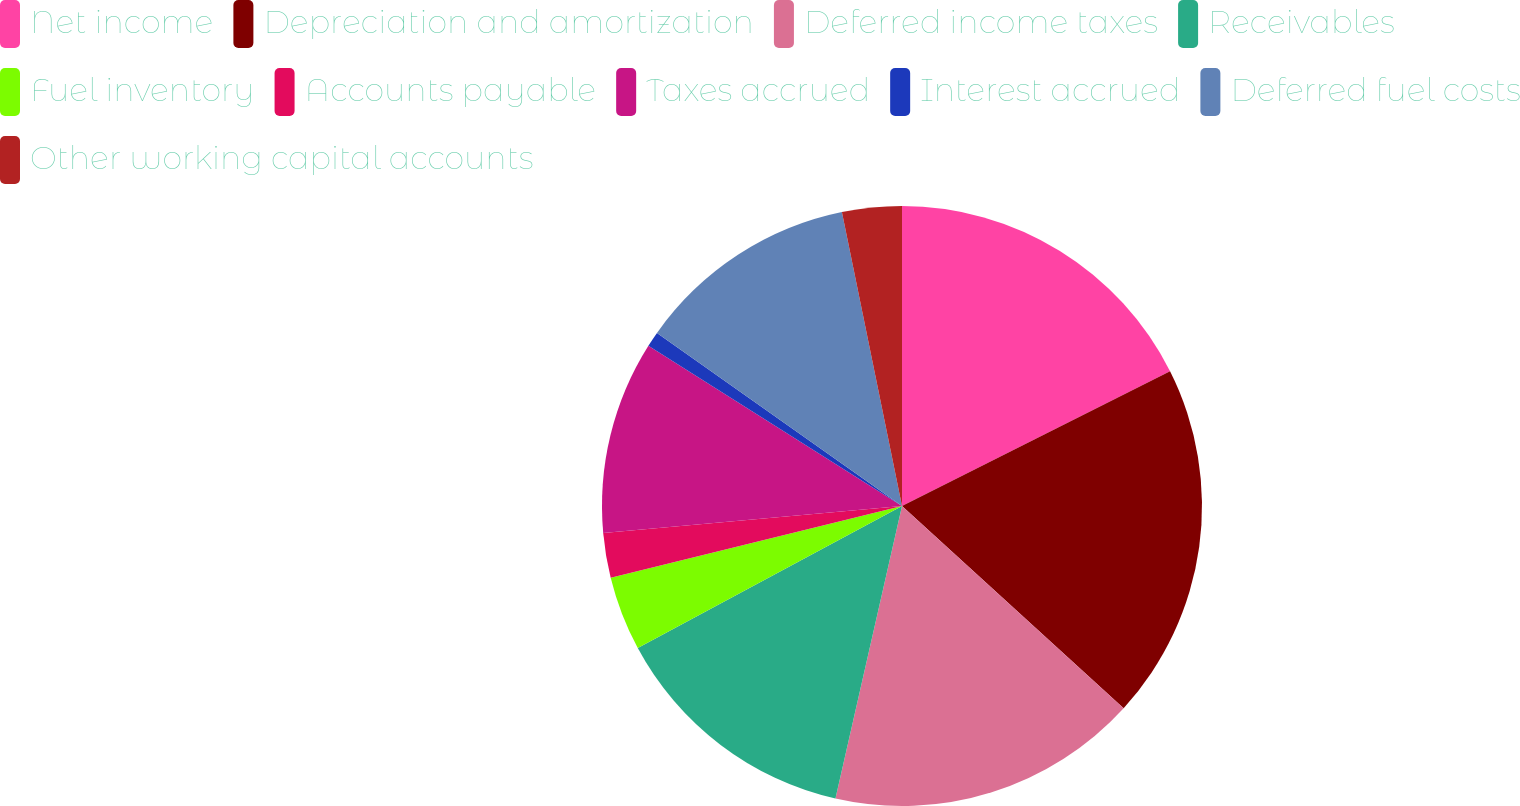<chart> <loc_0><loc_0><loc_500><loc_500><pie_chart><fcel>Net income<fcel>Depreciation and amortization<fcel>Deferred income taxes<fcel>Receivables<fcel>Fuel inventory<fcel>Accounts payable<fcel>Taxes accrued<fcel>Interest accrued<fcel>Deferred fuel costs<fcel>Other working capital accounts<nl><fcel>17.59%<fcel>19.18%<fcel>16.79%<fcel>13.59%<fcel>4.01%<fcel>2.41%<fcel>10.4%<fcel>0.82%<fcel>12.0%<fcel>3.21%<nl></chart> 